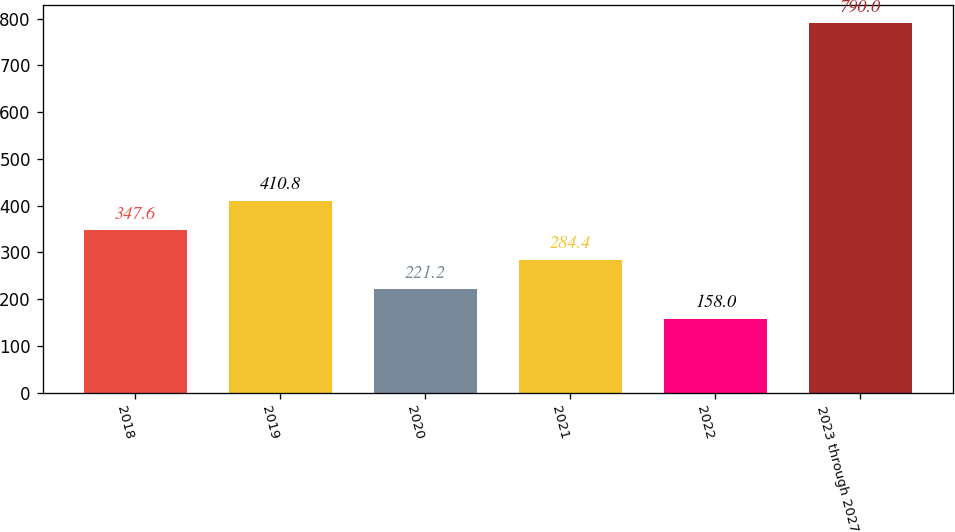<chart> <loc_0><loc_0><loc_500><loc_500><bar_chart><fcel>2018<fcel>2019<fcel>2020<fcel>2021<fcel>2022<fcel>2023 through 2027<nl><fcel>347.6<fcel>410.8<fcel>221.2<fcel>284.4<fcel>158<fcel>790<nl></chart> 